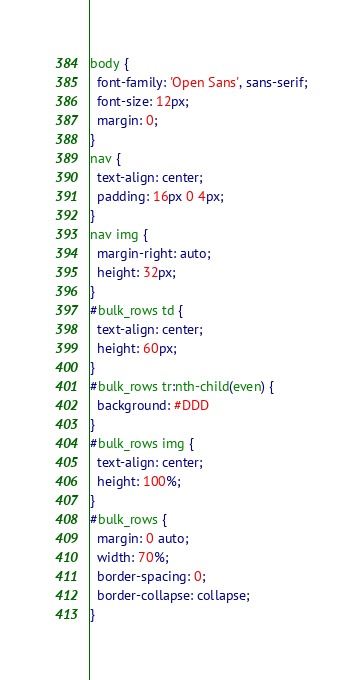<code> <loc_0><loc_0><loc_500><loc_500><_CSS_>body {
  font-family: 'Open Sans', sans-serif;
  font-size: 12px;
  margin: 0;
}
nav {
  text-align: center;
  padding: 16px 0 4px;
}
nav img {
  margin-right: auto;
  height: 32px;
}
#bulk_rows td {
  text-align: center;
  height: 60px;
}
#bulk_rows tr:nth-child(even) {
  background: #DDD
}
#bulk_rows img {
  text-align: center;
  height: 100%;
}
#bulk_rows {
  margin: 0 auto;
  width: 70%;
  border-spacing: 0;
  border-collapse: collapse;
}
</code> 